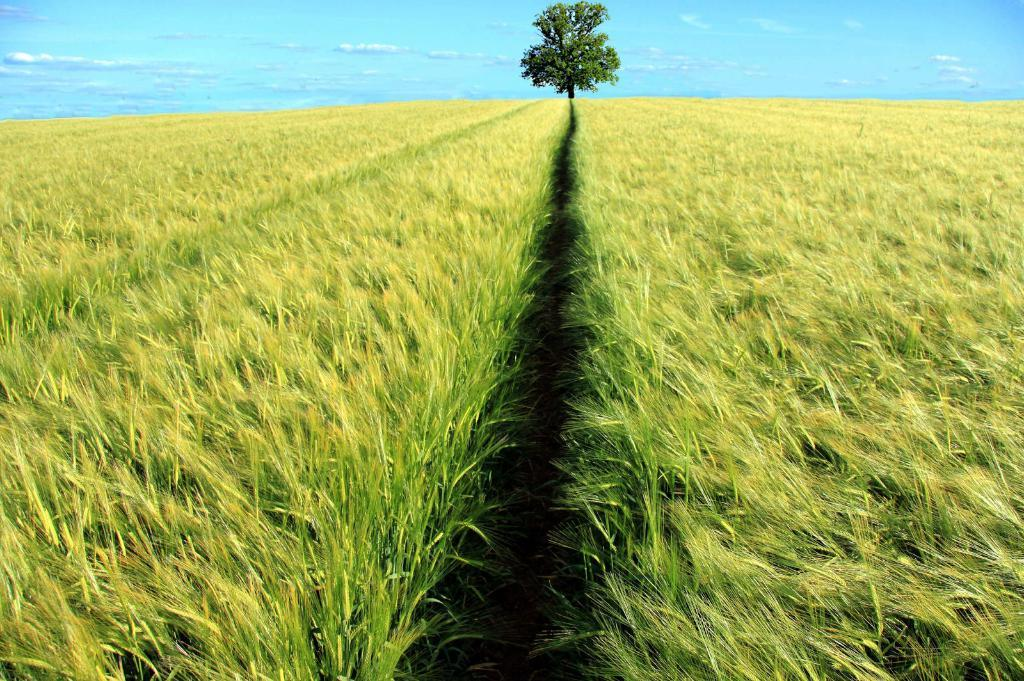What type of landscape is depicted in the image? The image features fields. Can you describe any other elements in the background of the image? There is a tree in the background of the image. What type of blood vessels can be seen in the tree in the image? There is no mention of blood vessels or any biological elements in the image; it simply features fields and a tree. 